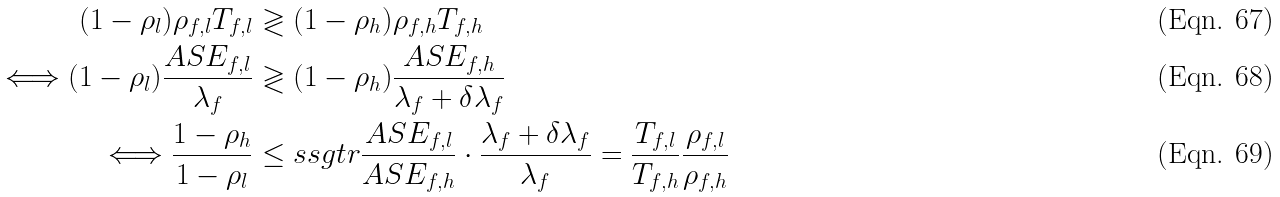<formula> <loc_0><loc_0><loc_500><loc_500>( 1 - \rho _ { l } ) \rho _ { f , l } T _ { f , l } & \gtrless ( 1 - \rho _ { h } ) \rho _ { f , h } T _ { f , h } \\ \Longleftrightarrow ( 1 - \rho _ { l } ) \frac { A S E _ { f , l } } { \lambda _ { f } } & \gtrless ( 1 - \rho _ { h } ) \frac { A S E _ { f , h } } { \lambda _ { f } + \delta \lambda _ { f } } \\ \Longleftrightarrow \frac { 1 - \rho _ { h } } { 1 - \rho _ { l } } & \leq s s g t r \frac { A S E _ { f , l } } { A S E _ { f , h } } \cdot \frac { \lambda _ { f } + \delta \lambda _ { f } } { \lambda _ { f } } = \frac { T _ { f , l } } { T _ { f , h } } \frac { \rho _ { f , l } } { \rho _ { f , h } }</formula> 